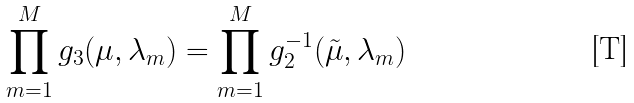<formula> <loc_0><loc_0><loc_500><loc_500>\prod _ { m = 1 } ^ { M } g _ { 3 } ( \mu , \lambda _ { m } ) = \prod _ { m = 1 } ^ { M } g ^ { - 1 } _ { 2 } ( \tilde { \mu } , \lambda _ { m } )</formula> 